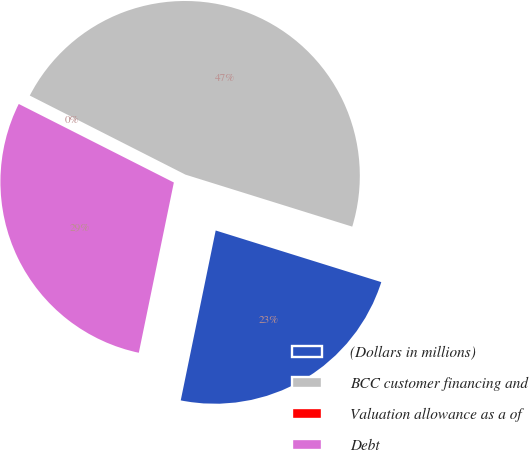<chart> <loc_0><loc_0><loc_500><loc_500><pie_chart><fcel>(Dollars in millions)<fcel>BCC customer financing and<fcel>Valuation allowance as a of<fcel>Debt<nl><fcel>23.42%<fcel>47.33%<fcel>0.02%<fcel>29.23%<nl></chart> 